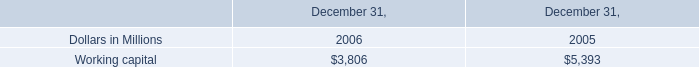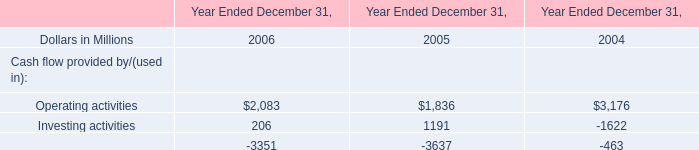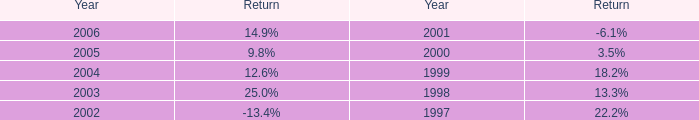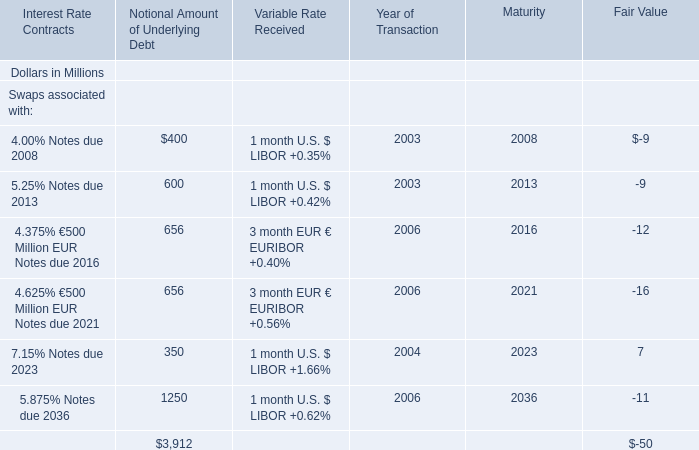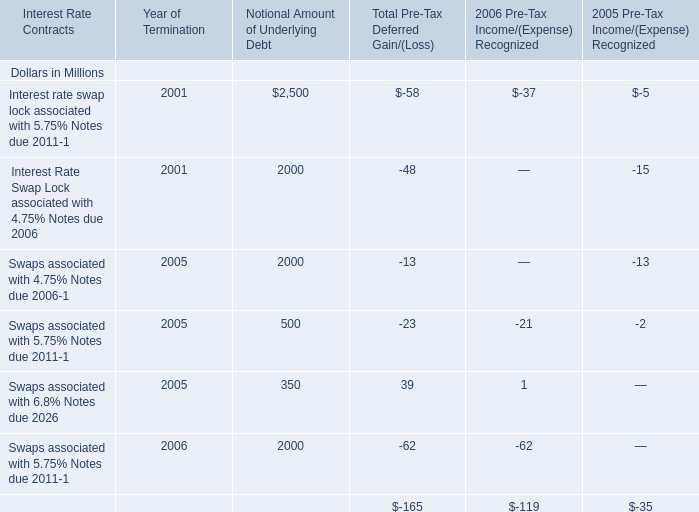How many Notional Amount of Underlying Debt exceed the average of 4.625% €500 Million EUR Notes due 2021 in 2016? 
Answer: 1. 